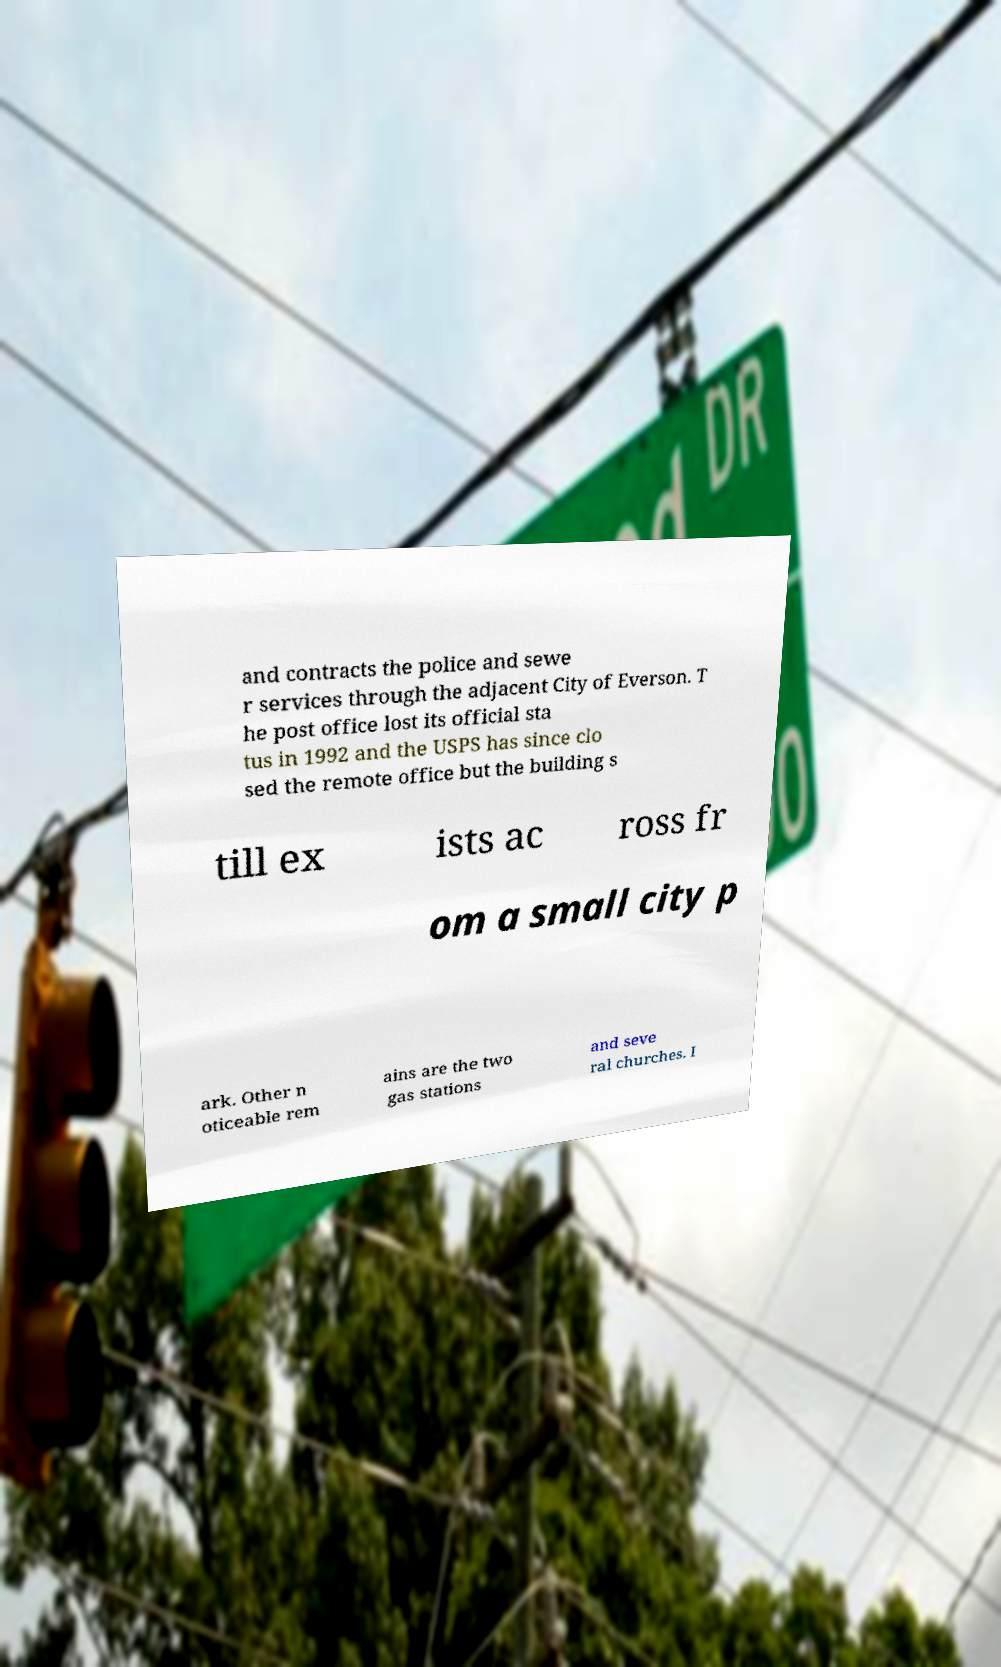Please read and relay the text visible in this image. What does it say? and contracts the police and sewe r services through the adjacent City of Everson. T he post office lost its official sta tus in 1992 and the USPS has since clo sed the remote office but the building s till ex ists ac ross fr om a small city p ark. Other n oticeable rem ains are the two gas stations and seve ral churches. I 